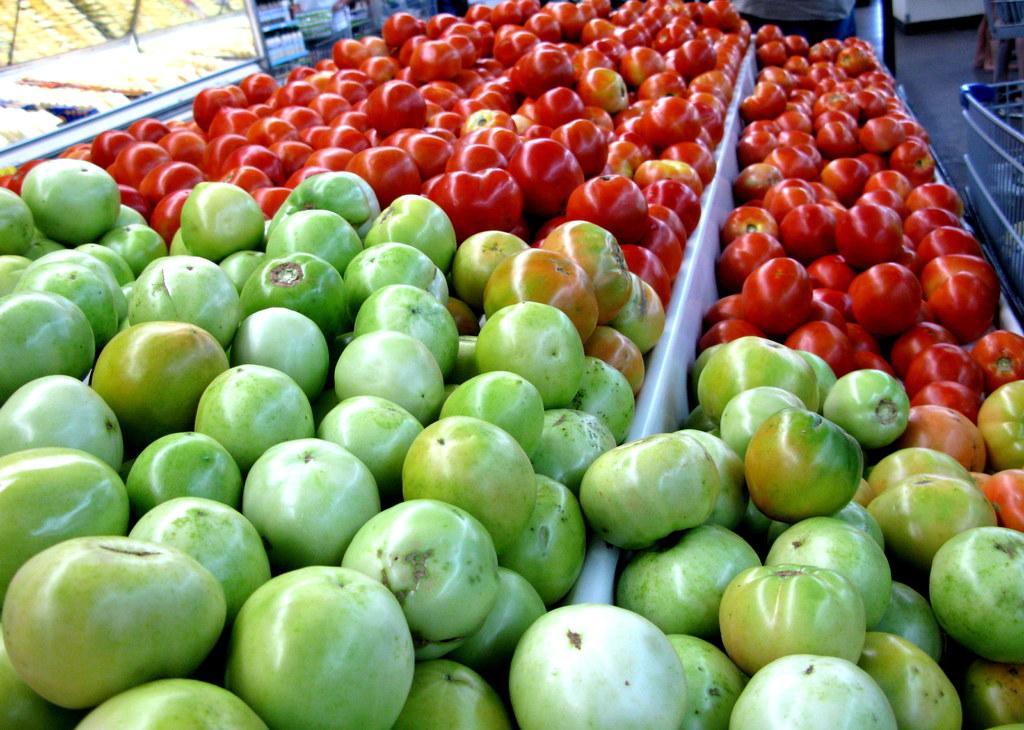Can you describe this image briefly? In this image there are tomatoes. 